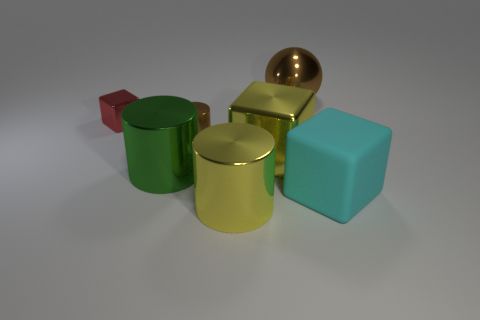Add 3 cyan blocks. How many objects exist? 10 Subtract all spheres. How many objects are left? 6 Subtract 1 cyan blocks. How many objects are left? 6 Subtract all small brown things. Subtract all tiny cylinders. How many objects are left? 5 Add 4 brown balls. How many brown balls are left? 5 Add 1 tiny purple metal cubes. How many tiny purple metal cubes exist? 1 